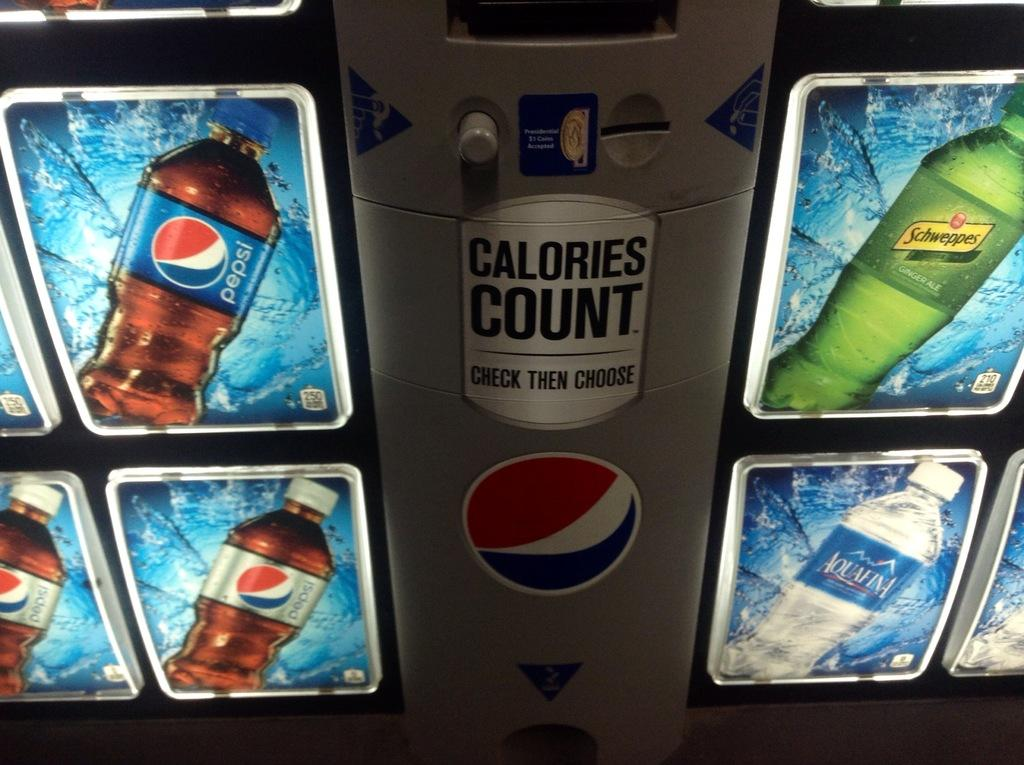What is the main object in the image? There is a machine in the image. What is displayed on the machine? The machine has a poster and a logo. How can the machine be operated? The machine has a button. What else can be seen in the corners of the image? There are images of bottles with logos in the left and right corners of the image. Can you see a tiger hiding behind the curtain in the image? There is no curtain or tiger present in the image. What type of park is visible in the image? There is no park visible in the image; it features a machine with a poster, logo, and button, along with images of bottles with logos in the corners. 